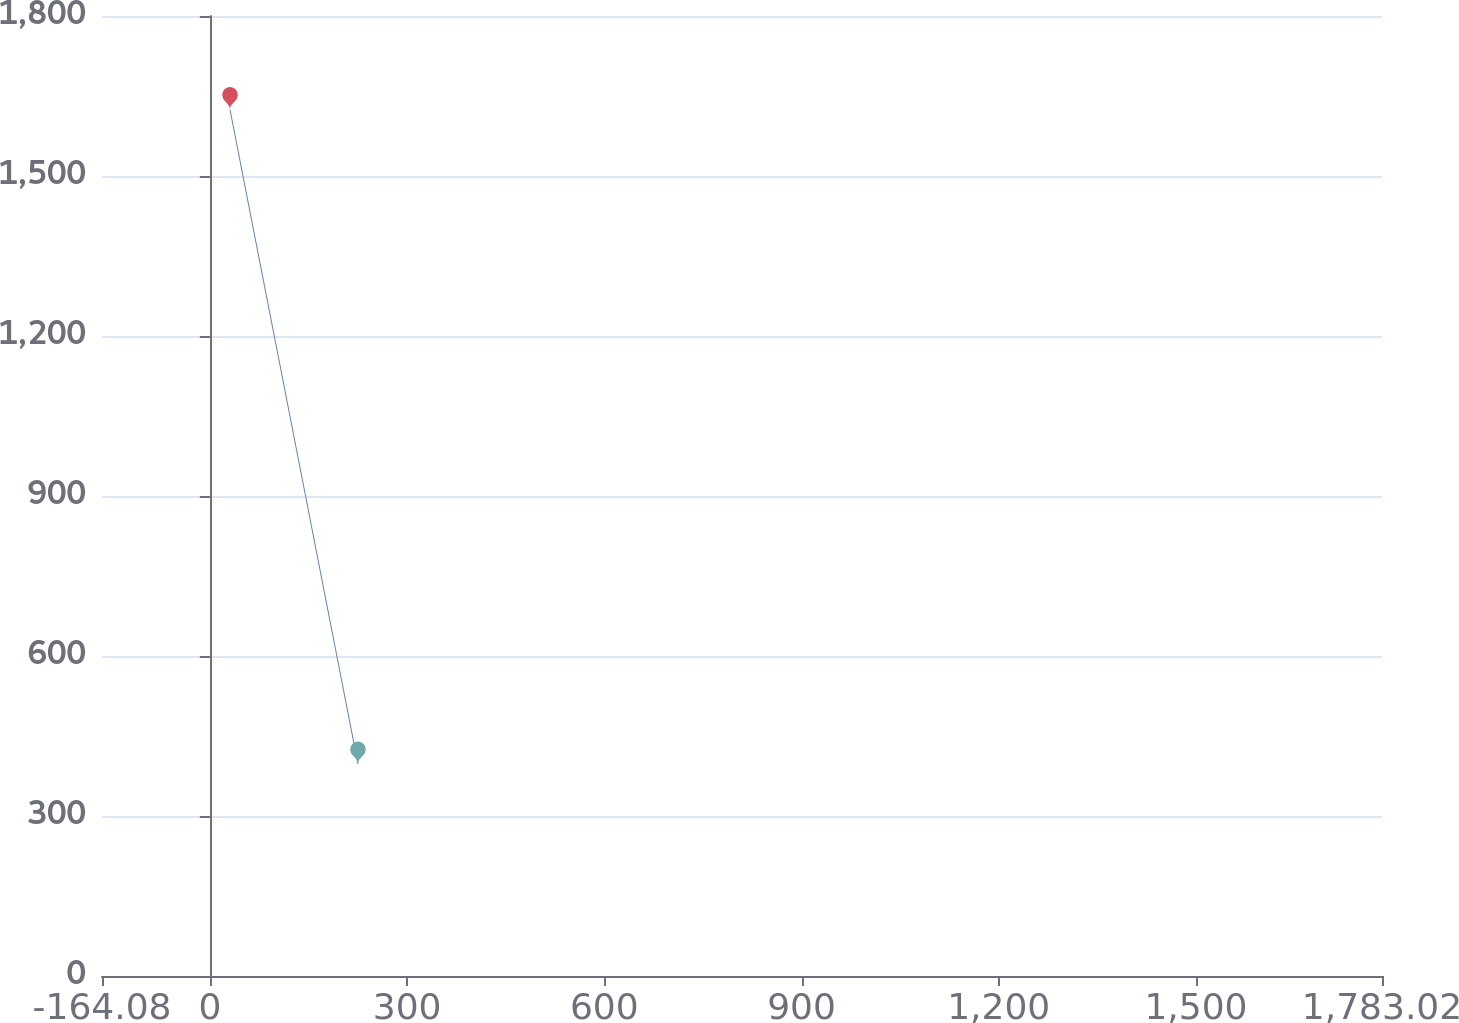Convert chart to OTSL. <chart><loc_0><loc_0><loc_500><loc_500><line_chart><ecel><fcel>Years Ended December 31,<nl><fcel>30.63<fcel>1624.33<nl><fcel>225.34<fcel>397.21<nl><fcel>1977.73<fcel>260.86<nl></chart> 